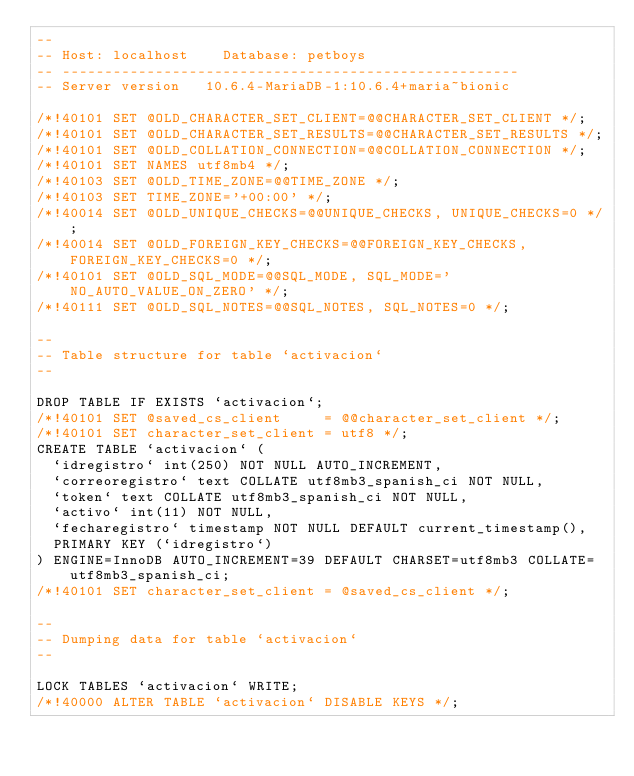Convert code to text. <code><loc_0><loc_0><loc_500><loc_500><_SQL_>--
-- Host: localhost    Database: petboys
-- ------------------------------------------------------
-- Server version	10.6.4-MariaDB-1:10.6.4+maria~bionic

/*!40101 SET @OLD_CHARACTER_SET_CLIENT=@@CHARACTER_SET_CLIENT */;
/*!40101 SET @OLD_CHARACTER_SET_RESULTS=@@CHARACTER_SET_RESULTS */;
/*!40101 SET @OLD_COLLATION_CONNECTION=@@COLLATION_CONNECTION */;
/*!40101 SET NAMES utf8mb4 */;
/*!40103 SET @OLD_TIME_ZONE=@@TIME_ZONE */;
/*!40103 SET TIME_ZONE='+00:00' */;
/*!40014 SET @OLD_UNIQUE_CHECKS=@@UNIQUE_CHECKS, UNIQUE_CHECKS=0 */;
/*!40014 SET @OLD_FOREIGN_KEY_CHECKS=@@FOREIGN_KEY_CHECKS, FOREIGN_KEY_CHECKS=0 */;
/*!40101 SET @OLD_SQL_MODE=@@SQL_MODE, SQL_MODE='NO_AUTO_VALUE_ON_ZERO' */;
/*!40111 SET @OLD_SQL_NOTES=@@SQL_NOTES, SQL_NOTES=0 */;

--
-- Table structure for table `activacion`
--

DROP TABLE IF EXISTS `activacion`;
/*!40101 SET @saved_cs_client     = @@character_set_client */;
/*!40101 SET character_set_client = utf8 */;
CREATE TABLE `activacion` (
  `idregistro` int(250) NOT NULL AUTO_INCREMENT,
  `correoregistro` text COLLATE utf8mb3_spanish_ci NOT NULL,
  `token` text COLLATE utf8mb3_spanish_ci NOT NULL,
  `activo` int(11) NOT NULL,
  `fecharegistro` timestamp NOT NULL DEFAULT current_timestamp(),
  PRIMARY KEY (`idregistro`)
) ENGINE=InnoDB AUTO_INCREMENT=39 DEFAULT CHARSET=utf8mb3 COLLATE=utf8mb3_spanish_ci;
/*!40101 SET character_set_client = @saved_cs_client */;

--
-- Dumping data for table `activacion`
--

LOCK TABLES `activacion` WRITE;
/*!40000 ALTER TABLE `activacion` DISABLE KEYS */;</code> 